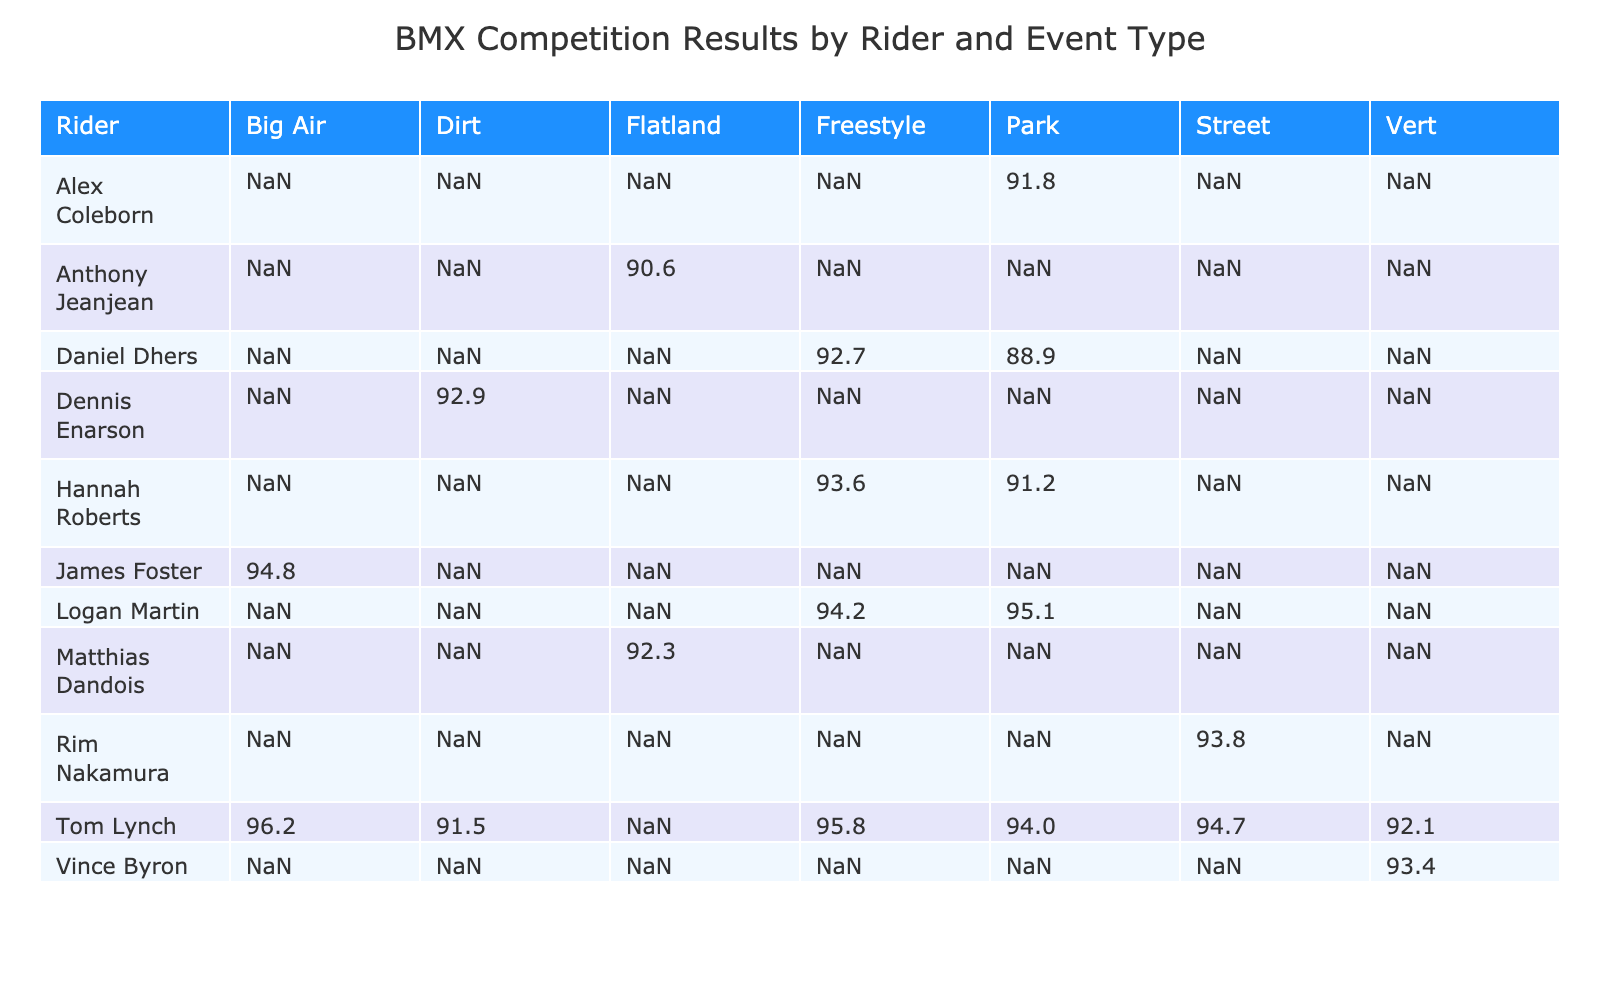What was Tom Lynch's highest score in any event? Looking at Tom Lynch's scores across different events, his highest score is 96.2 in the Big Air category at the X Games in 2023.
Answer: 96.2 In which event did Logan Martin achieve the greatest placement? Logan Martin placed 1st in the Park event at the UCI BMX World Cup in 2022, which is his greatest placement across all events listed.
Answer: 1st What is the average score of Hannah Roberts in the Freestyle and Park events? Hannah Roberts scored 93.6 in Freestyle and 91.2 in Park. To find the average, we add these scores (93.6 + 91.2 = 184.8) and then divide by the number of events (2). Therefore, the average score is 184.8 / 2 = 92.4.
Answer: 92.4 Did Tom Lynch ever place higher than Logan Martin in the Freestyle events? In the Freestyle events at the X Games in 2021, Tom Lynch did not compete; he only participated in Park and Street events. Therefore, we cannot say he placed higher than Logan Martin, who placed 2nd in Freestyle.
Answer: No Which rider has the highest average score across all events listed? First, we need to check the average scores for each rider. Tom Lynch has scores of 95.8, 93.5, 94.7, 91.5, 92.1, 96.2, and 94.5 in different events. Calculating the average gives us (95.8 + 93.5 + 94.7 + 91.5 + 92.1 + 96.2 + 94.5) / 7 = 94.6. Checking other riders, none exceed this, confirming Tom Lynch has the highest average score.
Answer: Tom Lynch How many events did Tom Lynch compete in? Reviewing the table, Tom Lynch is listed in 7 different events: Freestyle, Park, Street, Dirt, Vert, Big Air, and Park (in FISE World Series). Thus, he competed in a total of 7 events.
Answer: 7 events 